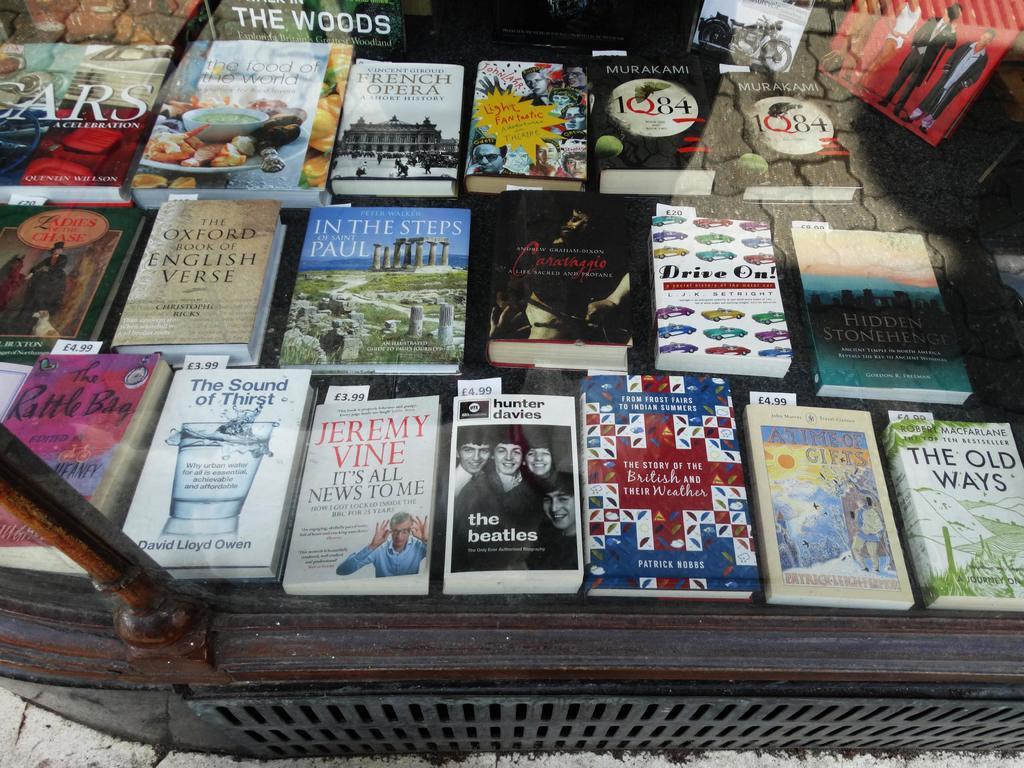What is the title of the book in the bottom right corner of the image?
Offer a very short reply. The old ways. 